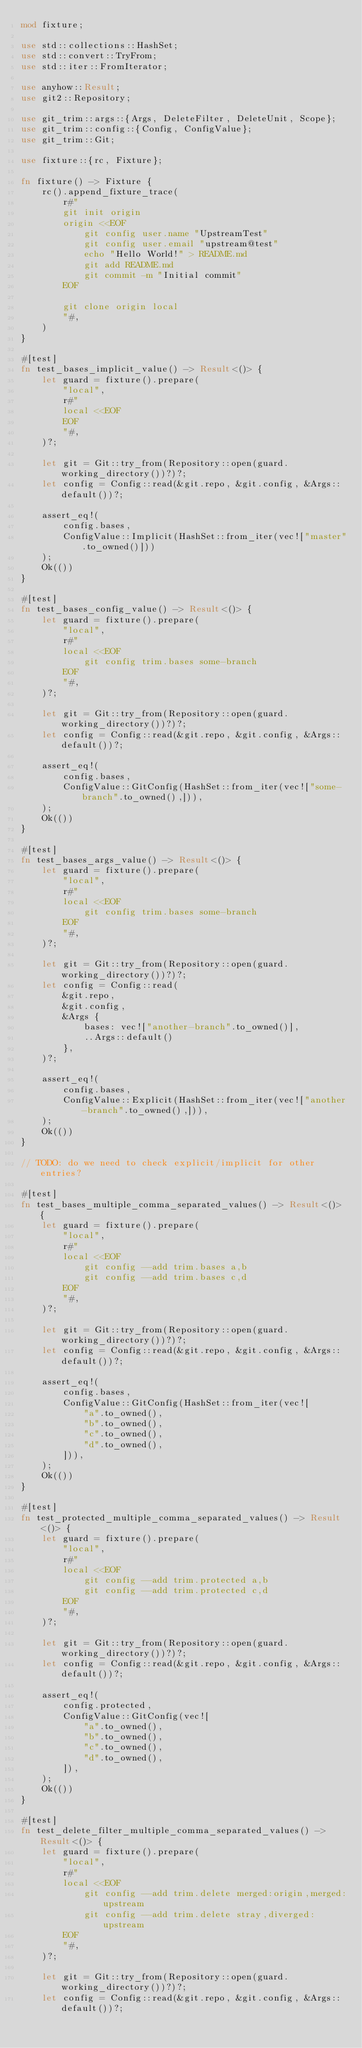<code> <loc_0><loc_0><loc_500><loc_500><_Rust_>mod fixture;

use std::collections::HashSet;
use std::convert::TryFrom;
use std::iter::FromIterator;

use anyhow::Result;
use git2::Repository;

use git_trim::args::{Args, DeleteFilter, DeleteUnit, Scope};
use git_trim::config::{Config, ConfigValue};
use git_trim::Git;

use fixture::{rc, Fixture};

fn fixture() -> Fixture {
    rc().append_fixture_trace(
        r#"
        git init origin
        origin <<EOF
            git config user.name "UpstreamTest"
            git config user.email "upstream@test"
            echo "Hello World!" > README.md
            git add README.md
            git commit -m "Initial commit"
        EOF

        git clone origin local
        "#,
    )
}

#[test]
fn test_bases_implicit_value() -> Result<()> {
    let guard = fixture().prepare(
        "local",
        r#"
        local <<EOF
        EOF
        "#,
    )?;

    let git = Git::try_from(Repository::open(guard.working_directory())?)?;
    let config = Config::read(&git.repo, &git.config, &Args::default())?;

    assert_eq!(
        config.bases,
        ConfigValue::Implicit(HashSet::from_iter(vec!["master".to_owned()]))
    );
    Ok(())
}

#[test]
fn test_bases_config_value() -> Result<()> {
    let guard = fixture().prepare(
        "local",
        r#"
        local <<EOF
            git config trim.bases some-branch
        EOF
        "#,
    )?;

    let git = Git::try_from(Repository::open(guard.working_directory())?)?;
    let config = Config::read(&git.repo, &git.config, &Args::default())?;

    assert_eq!(
        config.bases,
        ConfigValue::GitConfig(HashSet::from_iter(vec!["some-branch".to_owned(),])),
    );
    Ok(())
}

#[test]
fn test_bases_args_value() -> Result<()> {
    let guard = fixture().prepare(
        "local",
        r#"
        local <<EOF
            git config trim.bases some-branch
        EOF
        "#,
    )?;

    let git = Git::try_from(Repository::open(guard.working_directory())?)?;
    let config = Config::read(
        &git.repo,
        &git.config,
        &Args {
            bases: vec!["another-branch".to_owned()],
            ..Args::default()
        },
    )?;

    assert_eq!(
        config.bases,
        ConfigValue::Explicit(HashSet::from_iter(vec!["another-branch".to_owned(),])),
    );
    Ok(())
}

// TODO: do we need to check explicit/implicit for other entries?

#[test]
fn test_bases_multiple_comma_separated_values() -> Result<()> {
    let guard = fixture().prepare(
        "local",
        r#"
        local <<EOF
            git config --add trim.bases a,b
            git config --add trim.bases c,d
        EOF
        "#,
    )?;

    let git = Git::try_from(Repository::open(guard.working_directory())?)?;
    let config = Config::read(&git.repo, &git.config, &Args::default())?;

    assert_eq!(
        config.bases,
        ConfigValue::GitConfig(HashSet::from_iter(vec![
            "a".to_owned(),
            "b".to_owned(),
            "c".to_owned(),
            "d".to_owned(),
        ])),
    );
    Ok(())
}

#[test]
fn test_protected_multiple_comma_separated_values() -> Result<()> {
    let guard = fixture().prepare(
        "local",
        r#"
        local <<EOF
            git config --add trim.protected a,b
            git config --add trim.protected c,d
        EOF
        "#,
    )?;

    let git = Git::try_from(Repository::open(guard.working_directory())?)?;
    let config = Config::read(&git.repo, &git.config, &Args::default())?;

    assert_eq!(
        config.protected,
        ConfigValue::GitConfig(vec![
            "a".to_owned(),
            "b".to_owned(),
            "c".to_owned(),
            "d".to_owned(),
        ]),
    );
    Ok(())
}

#[test]
fn test_delete_filter_multiple_comma_separated_values() -> Result<()> {
    let guard = fixture().prepare(
        "local",
        r#"
        local <<EOF
            git config --add trim.delete merged:origin,merged:upstream
            git config --add trim.delete stray,diverged:upstream
        EOF
        "#,
    )?;

    let git = Git::try_from(Repository::open(guard.working_directory())?)?;
    let config = Config::read(&git.repo, &git.config, &Args::default())?;
</code> 